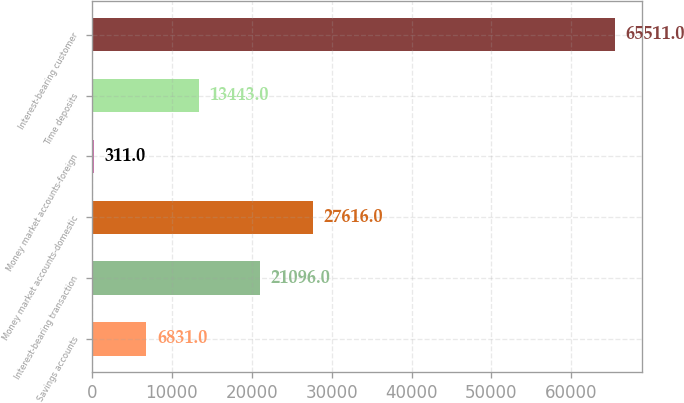Convert chart. <chart><loc_0><loc_0><loc_500><loc_500><bar_chart><fcel>Savings accounts<fcel>Interest-bearing transaction<fcel>Money market accounts-domestic<fcel>Money market accounts-foreign<fcel>Time deposits<fcel>Interest-bearing customer<nl><fcel>6831<fcel>21096<fcel>27616<fcel>311<fcel>13443<fcel>65511<nl></chart> 